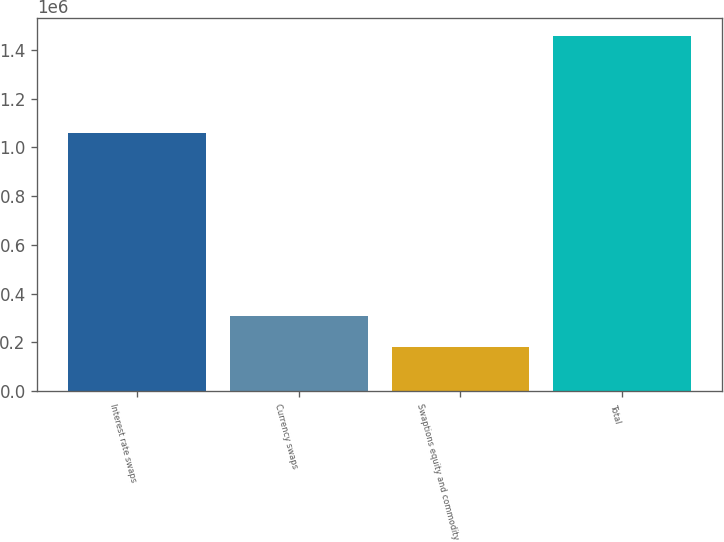Convert chart to OTSL. <chart><loc_0><loc_0><loc_500><loc_500><bar_chart><fcel>Interest rate swaps<fcel>Currency swaps<fcel>Swaptions equity and commodity<fcel>Total<nl><fcel>1.05828e+06<fcel>307677<fcel>180040<fcel>1.45641e+06<nl></chart> 